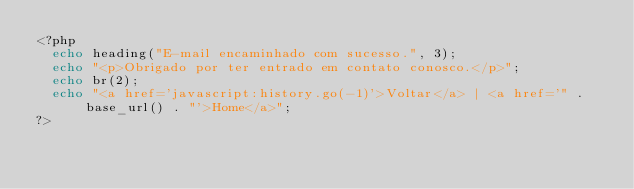Convert code to text. <code><loc_0><loc_0><loc_500><loc_500><_PHP_><?php 
	echo heading("E-mail encaminhado com sucesso.", 3);
	echo "<p>Obrigado por ter entrado em contato conosco.</p>";
	echo br(2);
	echo "<a href='javascript:history.go(-1)'>Voltar</a> | <a href='" . base_url() . "'>Home</a>";
?></code> 